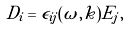<formula> <loc_0><loc_0><loc_500><loc_500>D _ { i } = \tilde { \epsilon } _ { i j } ( \omega , k ) E _ { j } ,</formula> 